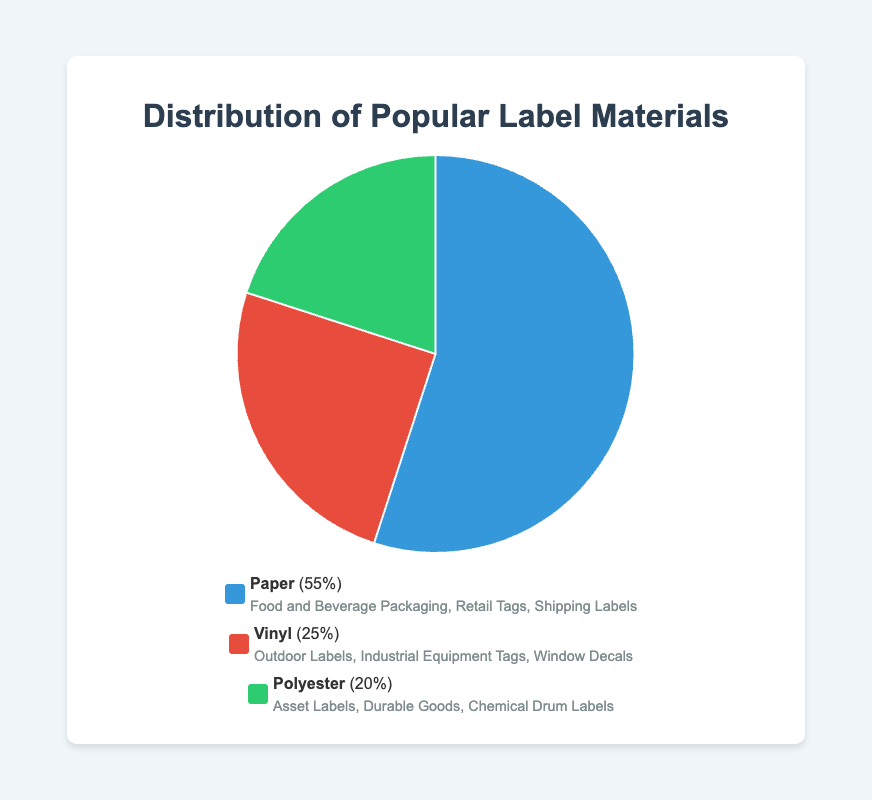What percentage of the total labels are made from vinyl and polyester combined? Vinyl represents 25% and polyester represents 20%. Adding these percentages together gives us 25% + 20% = 45%.
Answer: 45% What is the most commonly used material for labels? The pie chart shows that paper accounts for 55%, making it the most commonly used material.
Answer: Paper Which material type is least present in the distribution? Polyester accounts for 20%, which is less than both paper (55%) and vinyl (25%).
Answer: Polyester How much more prevalent is paper than vinyl in label materials? Paper constitutes 55% and vinyl 25%. The difference between them is 55% - 25% = 30%.
Answer: 30% What applications do paper labels cover? The legend lists paper applications as Food and Beverage Packaging, Retail Tags, and Shipping Labels.
Answer: Food and Beverage Packaging, Retail Tags, Shipping Labels Which material type has the second-largest share of the label market? Vinyl has the second-largest share at 25%, as it falls between paper (55%) and polyester (20%).
Answer: Vinyl Compare the combined percentage of vinyl and polyester to paper. Which is larger, and by how much? Vinyl and polyester combined make up 45%. Paper alone is 55%. Paper is larger by 55% - 45% = 10%.
Answer: Paper, 10% What color represents the polyester segment in the pie chart? The legend shows polyester is marked in green.
Answer: Green 